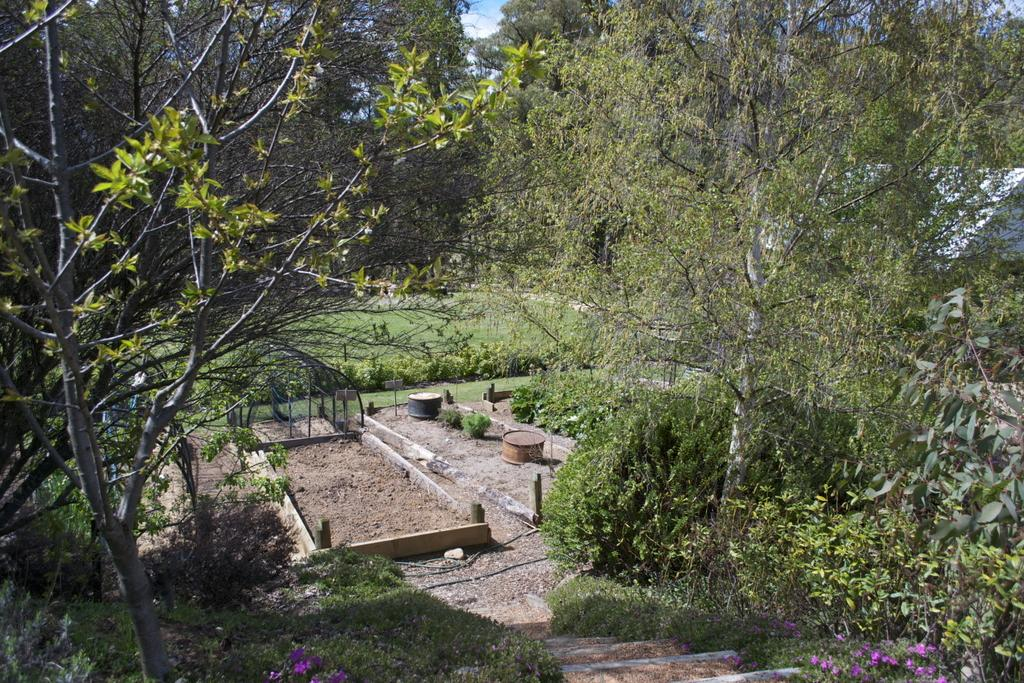What type of living organisms can be seen in the image? Plants and flowers are visible in the image. What structure can be seen on the right side of the image? There appears to be a house on the right side of the image. What type of vegetation is visible in the background of the image? There are trees in the background of the image. What is visible in the background of the image besides the trees? The sky is visible in the background of the image. What type of doll can be seen holding a rose in the image? There is no doll or rose present in the image. What type of acoustics can be heard in the image? The image is a still picture, so there are no sounds or acoustics present. 